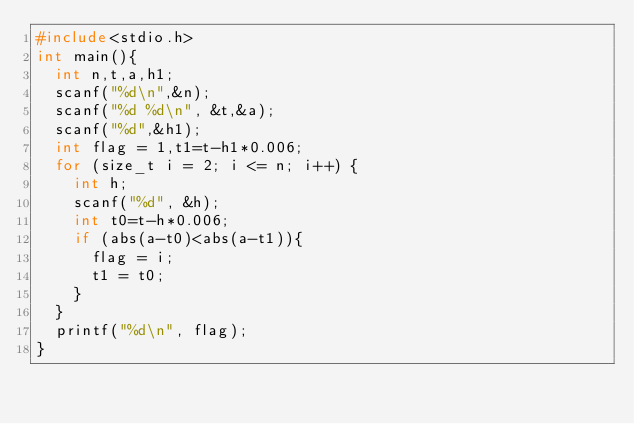Convert code to text. <code><loc_0><loc_0><loc_500><loc_500><_C_>#include<stdio.h>
int main(){
  int n,t,a,h1;
  scanf("%d\n",&n);
  scanf("%d %d\n", &t,&a);
  scanf("%d",&h1);
  int flag = 1,t1=t-h1*0.006;
  for (size_t i = 2; i <= n; i++) {
    int h;
    scanf("%d", &h);
    int t0=t-h*0.006;
    if (abs(a-t0)<abs(a-t1)){
      flag = i;
      t1 = t0;
    }
  }
  printf("%d\n", flag);
}
</code> 